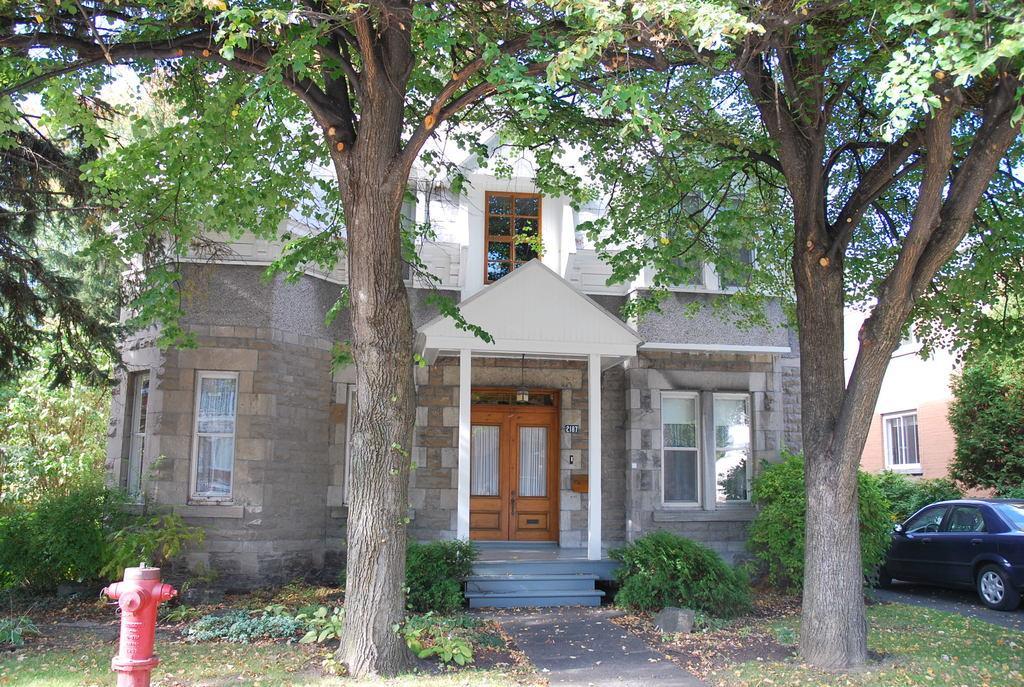In one or two sentences, can you explain what this image depicts? In this image we can see a building with doors and windows and there is a car and a building on the right side of the image. We can see some plants and trees and there is a fire hydrant on the left side of the image. 